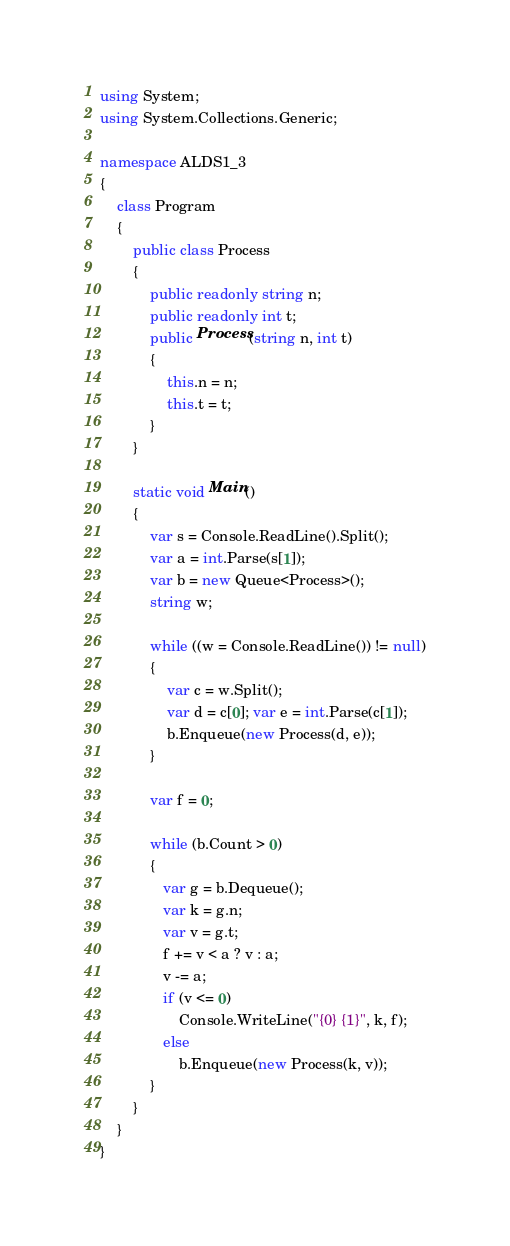<code> <loc_0><loc_0><loc_500><loc_500><_C#_>using System;
using System.Collections.Generic;
  
namespace ALDS1_3
{
    class Program
    {
        public class Process
        {
            public readonly string n;
            public readonly int t;
            public Process(string n, int t)
            {
                this.n = n;
                this.t = t;
            }
        }
  
        static void Main()
        {
            var s = Console.ReadLine().Split();
            var a = int.Parse(s[1]);
            var b = new Queue<Process>();
            string w;
 
            while ((w = Console.ReadLine()) != null)
            {
                var c = w.Split();
                var d = c[0]; var e = int.Parse(c[1]);
                b.Enqueue(new Process(d, e));
            }
  
            var f = 0;
  
            while (b.Count > 0)
            {
               var g = b.Dequeue();
               var k = g.n;
               var v = g.t;
               f += v < a ? v : a;
               v -= a;
               if (v <= 0)
                   Console.WriteLine("{0} {1}", k, f);
               else
                   b.Enqueue(new Process(k, v));
            }
        }
    }
}</code> 